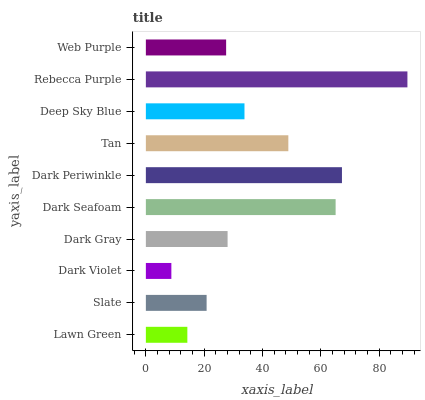Is Dark Violet the minimum?
Answer yes or no. Yes. Is Rebecca Purple the maximum?
Answer yes or no. Yes. Is Slate the minimum?
Answer yes or no. No. Is Slate the maximum?
Answer yes or no. No. Is Slate greater than Lawn Green?
Answer yes or no. Yes. Is Lawn Green less than Slate?
Answer yes or no. Yes. Is Lawn Green greater than Slate?
Answer yes or no. No. Is Slate less than Lawn Green?
Answer yes or no. No. Is Deep Sky Blue the high median?
Answer yes or no. Yes. Is Dark Gray the low median?
Answer yes or no. Yes. Is Dark Violet the high median?
Answer yes or no. No. Is Rebecca Purple the low median?
Answer yes or no. No. 